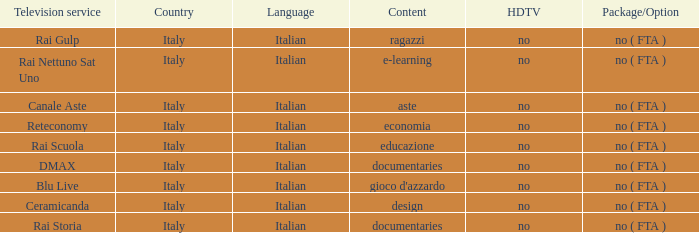What is the HDTV for the Rai Nettuno Sat Uno Television service? No. 